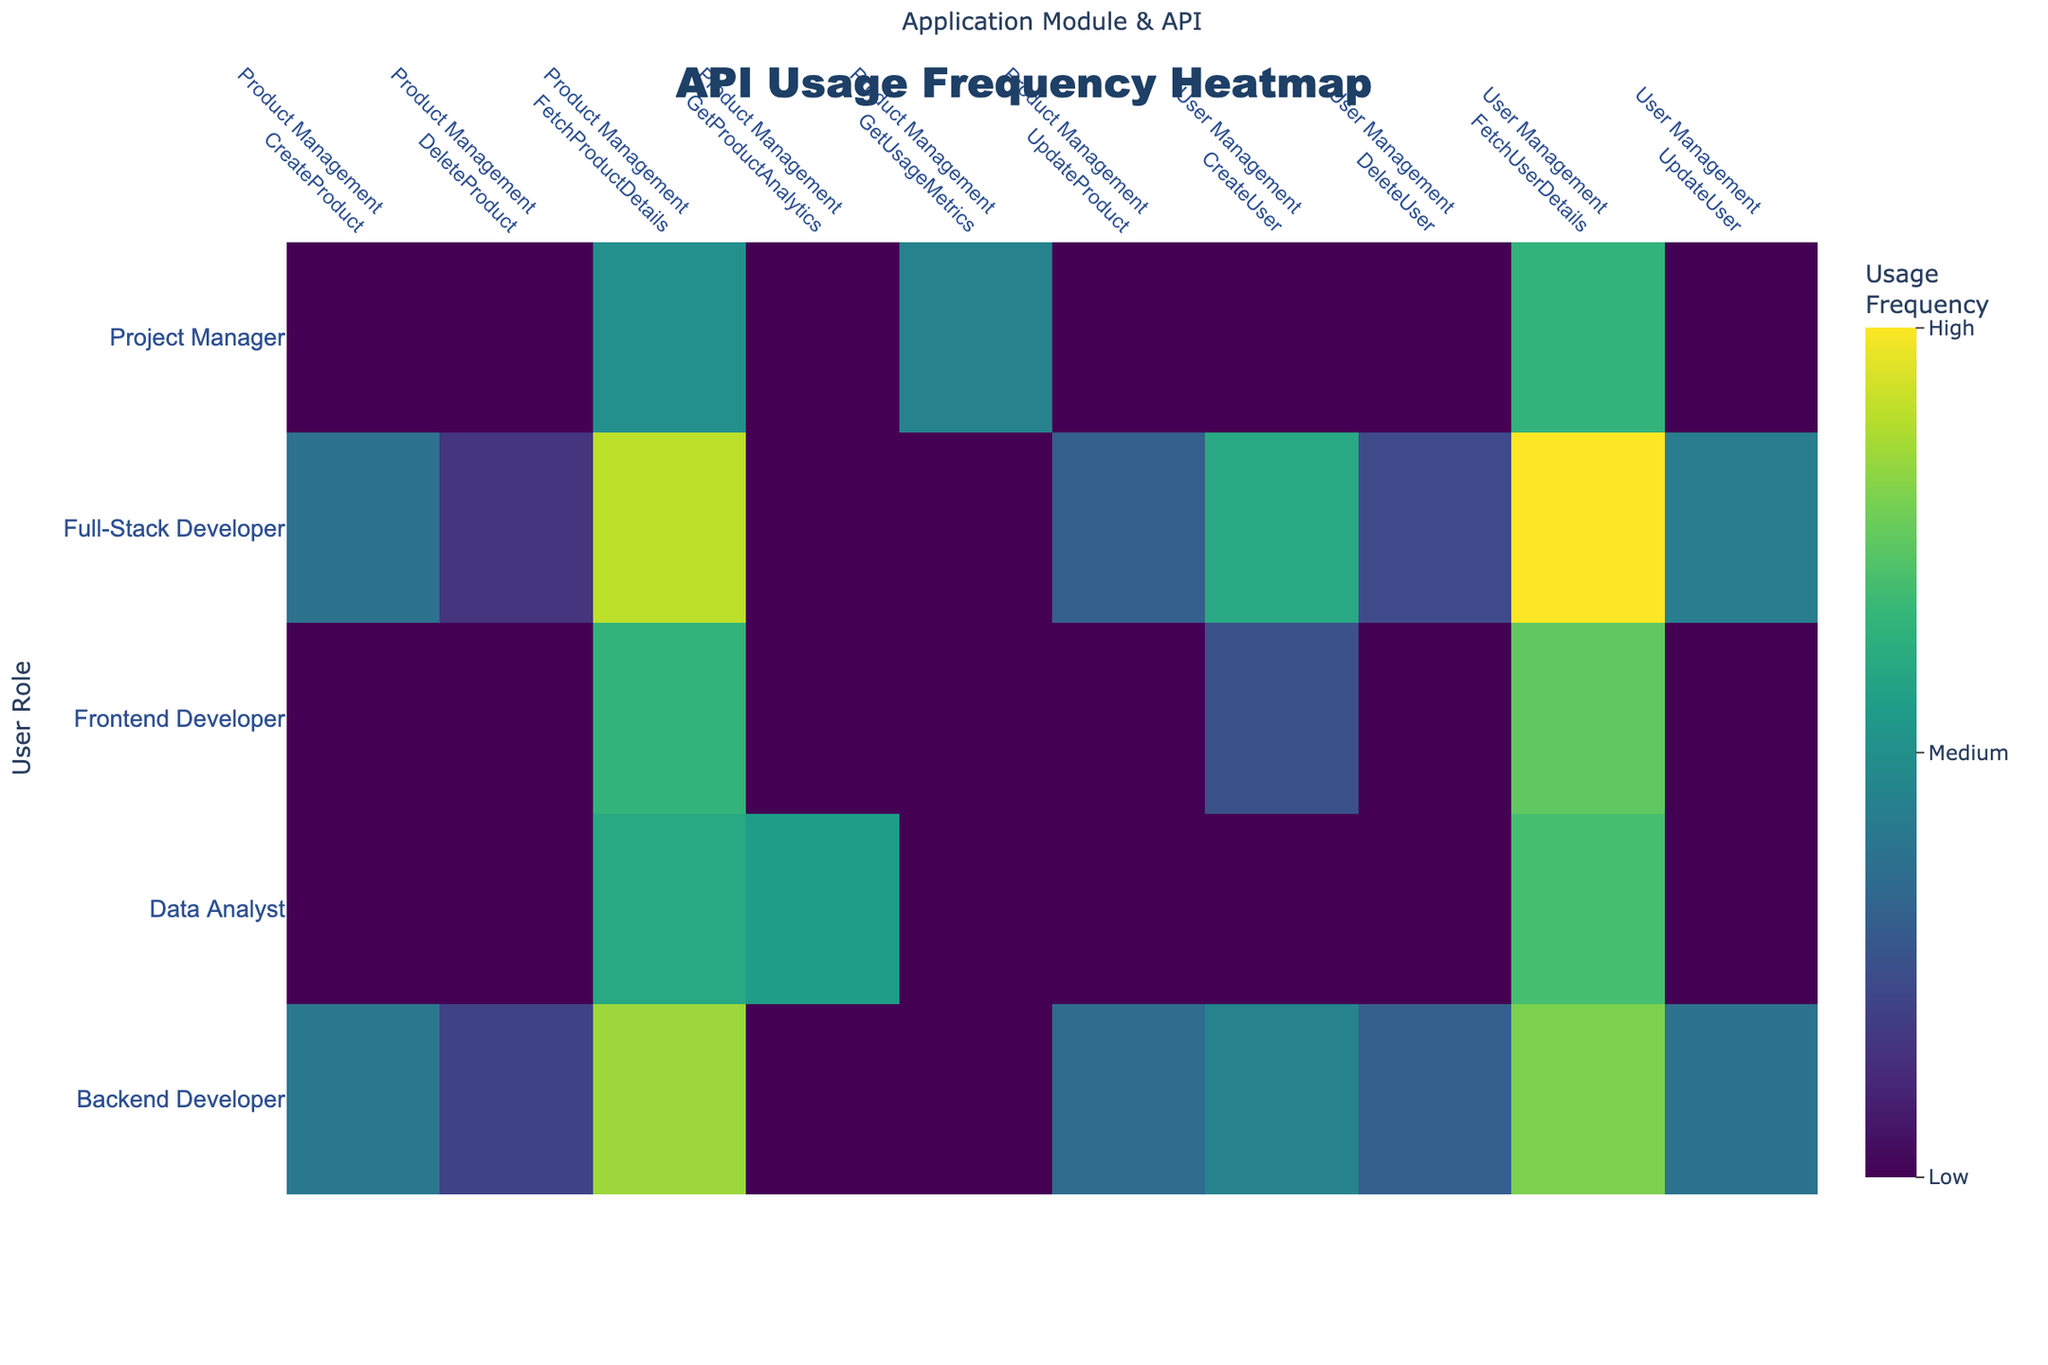What's the title of the heatmap? The title is usually displayed at the top center of the figure. By reading the directly provided information from the plot, we can determine the title.
Answer: API Usage Frequency Heatmap What are the labels of the x-axis and y-axis? The x-axis and y-axis labels often indicate what the respective axes represent. In this plot, they are typically shown just below or next to the axes.
Answer: The x-axis label is "Application Module & API" and the y-axis label is "User Role" Which user role uses the 'FetchUserDetails' API the most frequently? We need to identify the highest value for 'FetchUserDetails' across the different user roles indicated on the y-axis and find the corresponding user role.
Answer: Full-Stack Developer What color scale is used in the heatmap? The color scale indicating the gradient representing the usage frequencies is identified by the range of colors shown in the legend or the plot.
Answer: Viridis What's the usage frequency for the 'CreateUser' API in the User Management module by Backend Developers? Look for the intersection of the 'Backend Developer' row and 'User Management<br>CreateUser' column in the heatmap. The value at this intersection is the usage frequency.
Answer: 90 Which API in the Product Management module is used the least frequently by Full-Stack Developers? Within the rows for 'Full-Stack Developer' and columns under 'Product Management', find the cell with the smallest value and identify the corresponding API.
Answer: DeleteProduct Which Application Module & API has the lowest usage frequency by any user role? Scan the heatmap for the cell with the lowest value and note the corresponding Application Module & API and the user role.
Answer: User Management<br>DeleteUser by Full-Stack Developer (45) Is there any user role that does not use a certain API? Look for any zero values in the heatmap which indicate non-usage, and specify which user role and API combination does not have any usage.
Answer: Yes. For example, 'Data Analyst' does not use 'CreateUser', 'DeleteUser', and 'UpdateUser' 